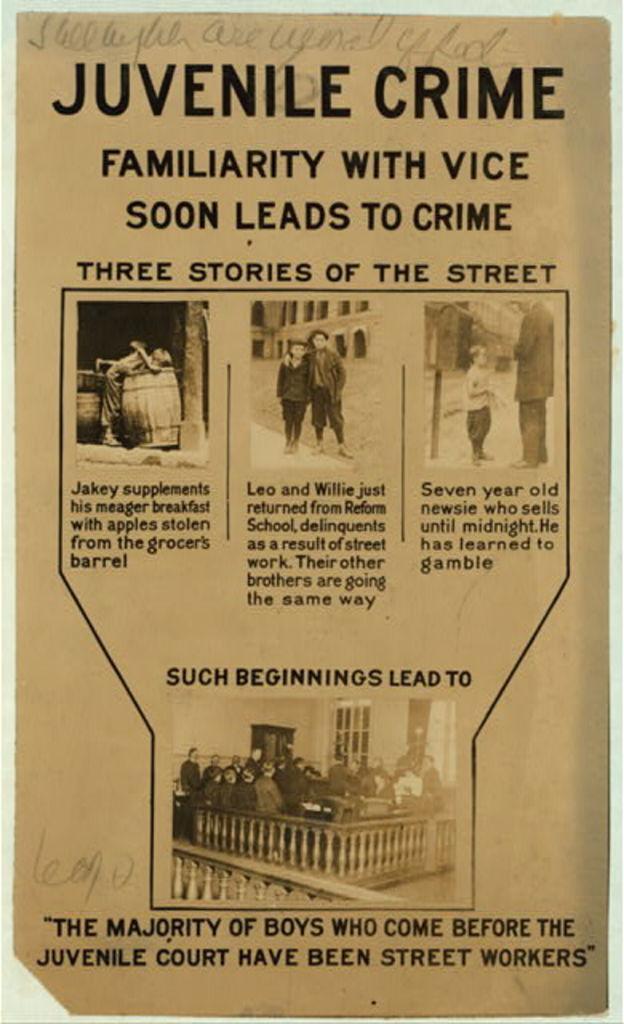Can you describe this image briefly? In the image there is a page and on the page there is some text and pictures. 